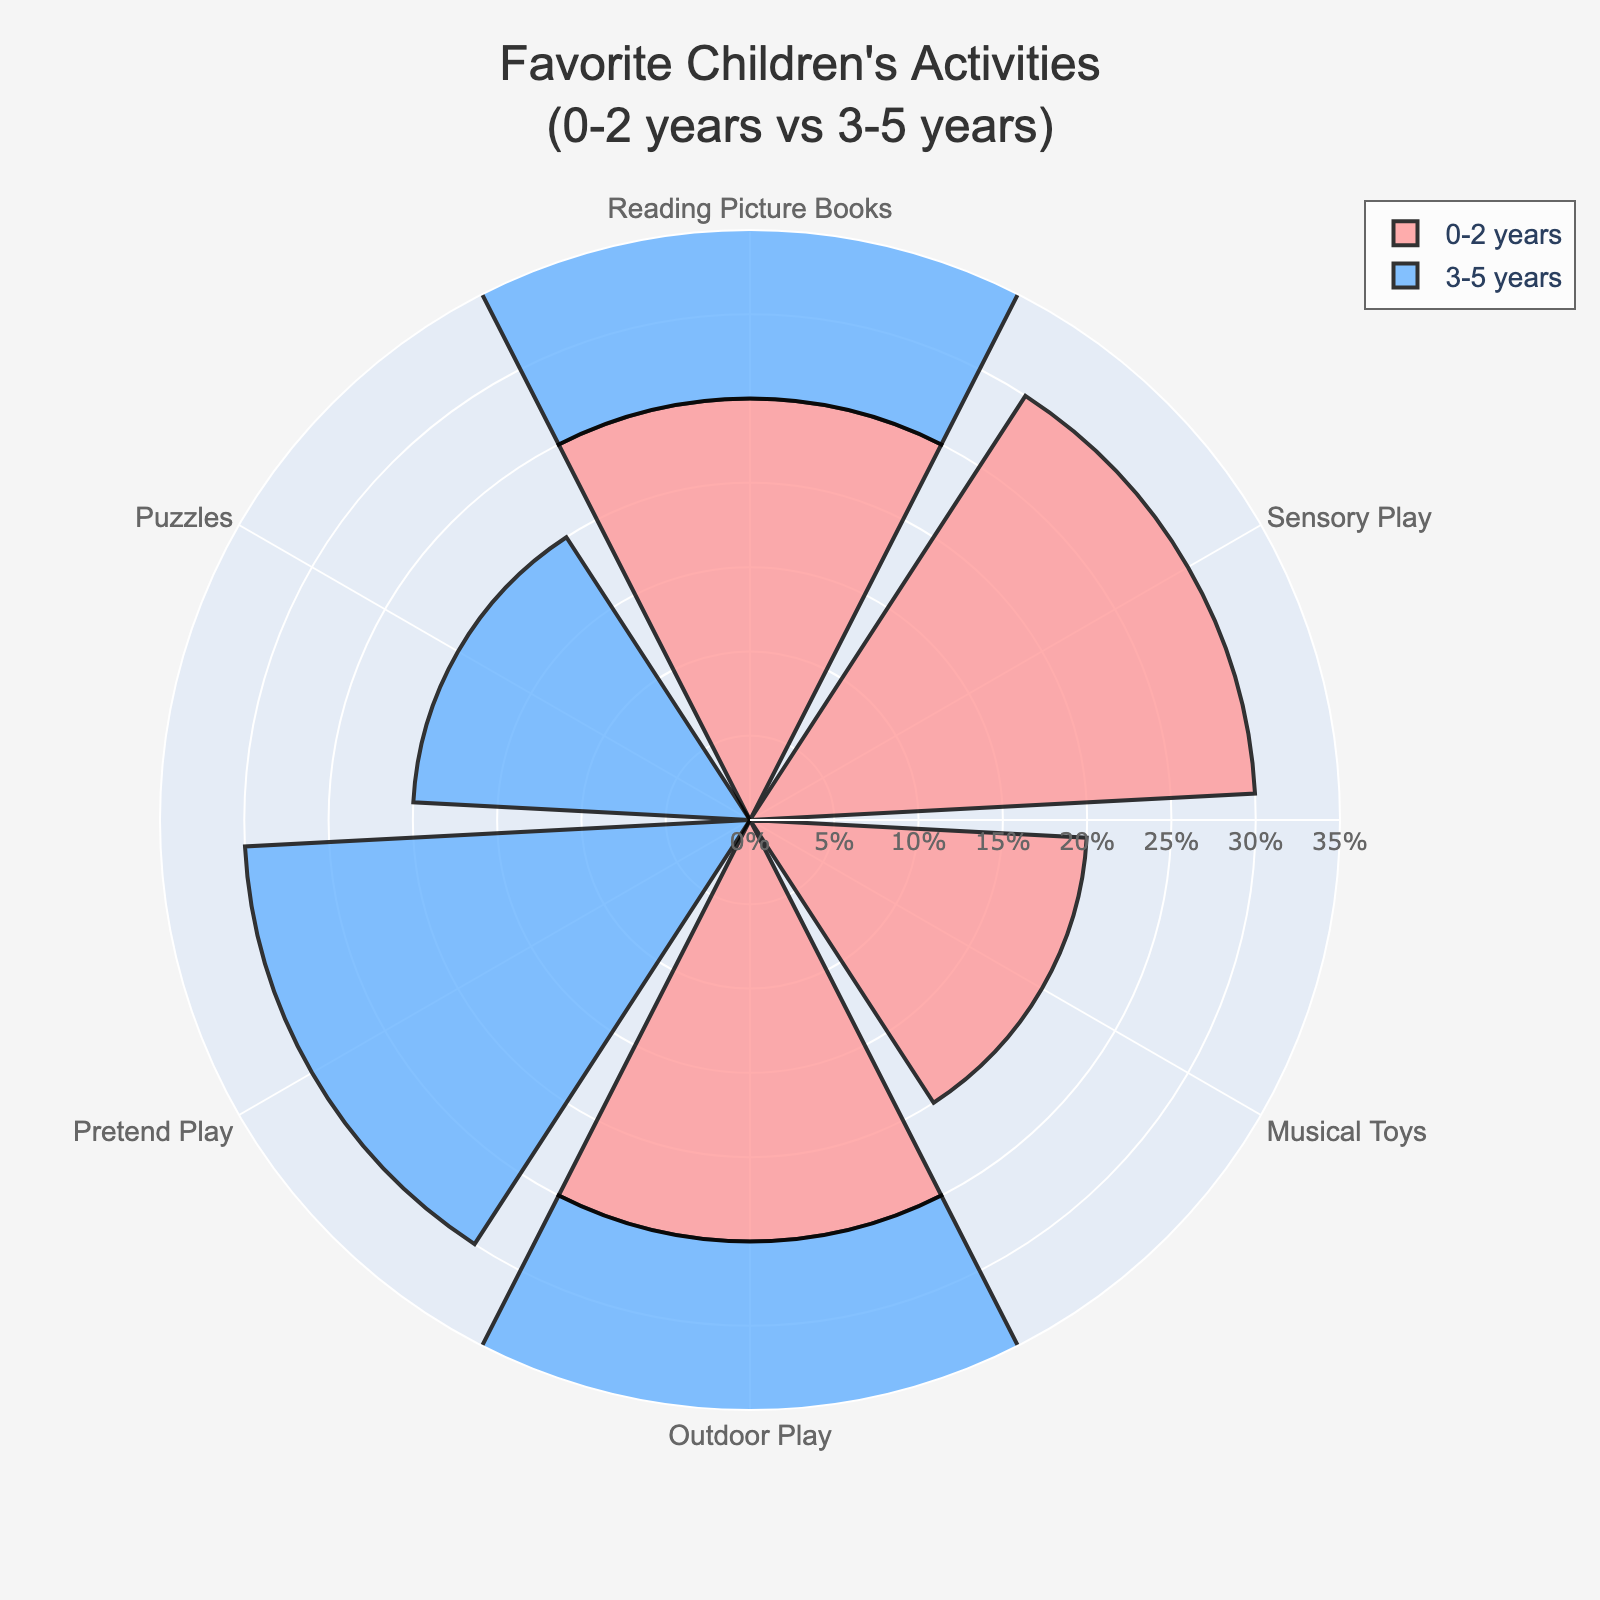What is the most popular activity for the 0-2 years age group? According to the chart, Sensory Play has the highest percentage for the 0-2 years age group.
Answer: Sensory Play Which age group has a preference for Pretend Play? By examining the chart, only the 3-5 years age group shows a percentage for Pretend Play, signifying their preference.
Answer: 3-5 years How does the popularity of Reading Picture Books compare between the 0-2 years and 3-5 years age groups? The chart indicates that both the 0-2 years and 3-5 years age groups have the same percentage for Reading Picture Books at 25%.
Answer: Equal What is the combined percentage for outdoor play across the 0-2 years and 3-5 years age groups? Outdoor Play is 25% for both 0-2 years and 3-5 years. Adding these gives 25% + 25% = 50%.
Answer: 50% Which activity appears in both age groups and has different popularity levels? Outdoor Play is present in both 0-2 years (25%) and 3-5 years (25%), but we need an activity with different levels. Reading Picture Books and sensory play are consistent between groups; the difference is in Sensory Play and Pretend Play.
Answer: Reading Picture Books What is the percentage difference between the most and least popular activities for the 0-2 years age group? Sensory Play and Musical Toys are the most and least popular in the 0-2 years age group, with 30% and 20% respectively. The difference is 30% - 20% = 10%.
Answer: 10% What are the shared preferences between the 0-2 years and 3-5 years age groups? Both age groups have Reading Picture Books and Outdoor Play activities, each picked by 25% of the children in both groups.
Answer: Reading Picture Books, Outdoor Play Compare the popularity of the most preferred activities between the 0-2 years and 3-5 years age groups. For the 0-2 years group, Sensory Play is the most preferred at 30%. For the 3-5 years group, Pretend Play also holds 30%. Therefore, they are equally preferred in their respective groups.
Answer: Equal By how much does the preference for Reading Picture Books change from the 0-2 years to the 3-5 years age group? For both age groups, the percentage is the same at 25%, resulting in a 0% change.
Answer: 0% 